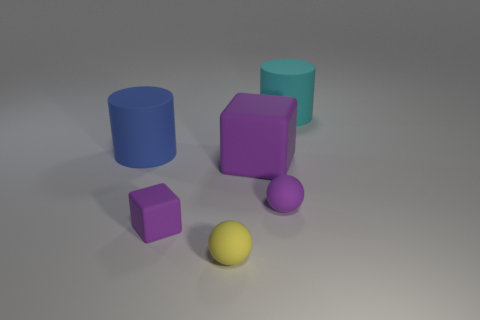How many objects are there in total, and can you describe their colors and shapes? There are five objects in total. Starting from the left, there is a blue cylinder, a purple cube, a purple prism, a cyan cylinder, and lastly, a yellow sphere. 